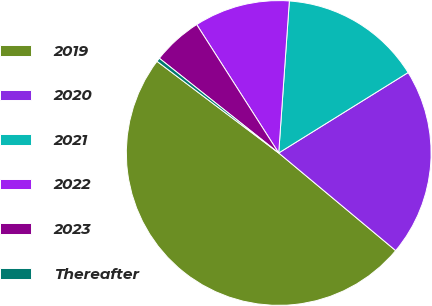<chart> <loc_0><loc_0><loc_500><loc_500><pie_chart><fcel>2019<fcel>2020<fcel>2021<fcel>2022<fcel>2023<fcel>Thereafter<nl><fcel>49.21%<fcel>19.92%<fcel>15.04%<fcel>10.16%<fcel>5.28%<fcel>0.4%<nl></chart> 